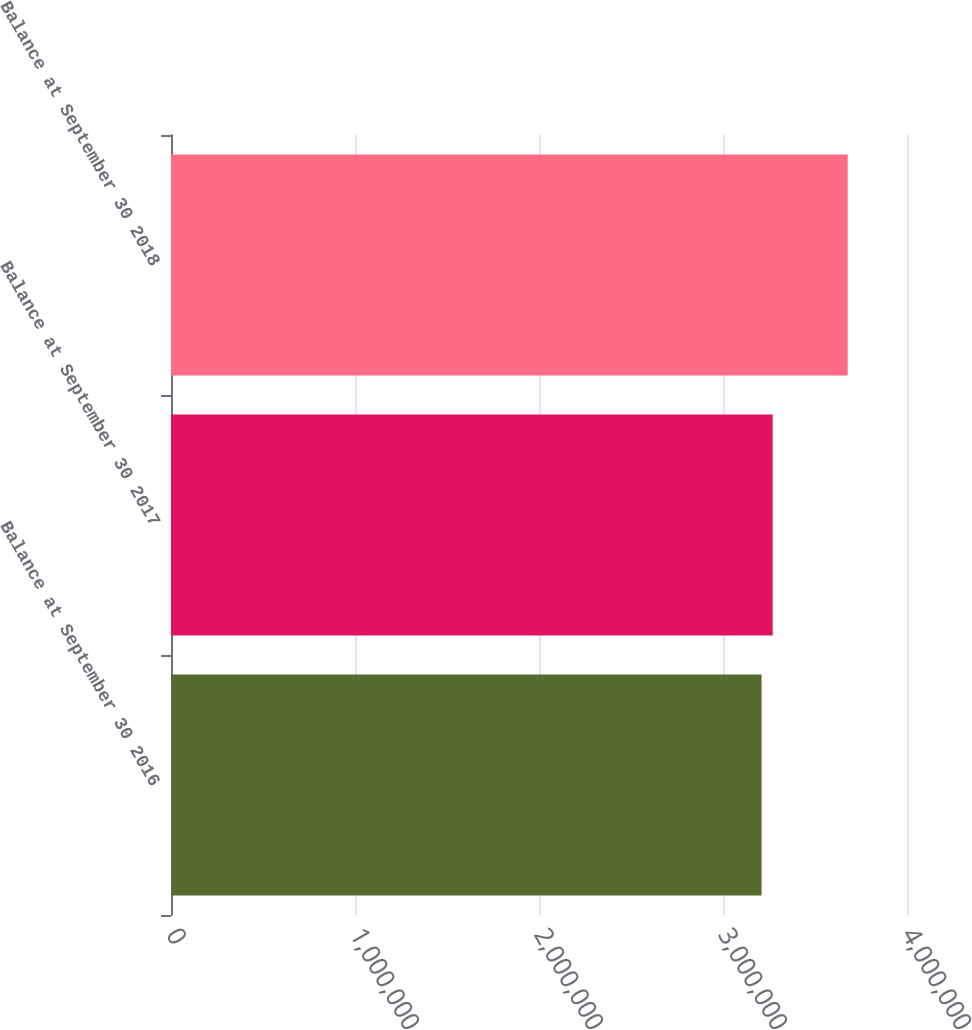Convert chart to OTSL. <chart><loc_0><loc_0><loc_500><loc_500><bar_chart><fcel>Balance at September 30 2016<fcel>Balance at September 30 2017<fcel>Balance at September 30 2018<nl><fcel>3.20958e+06<fcel>3.26998e+06<fcel>3.67768e+06<nl></chart> 